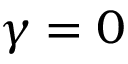Convert formula to latex. <formula><loc_0><loc_0><loc_500><loc_500>\gamma = 0</formula> 